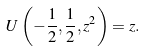Convert formula to latex. <formula><loc_0><loc_0><loc_500><loc_500>U \left ( - { \frac { 1 } { 2 } } , { \frac { 1 } { 2 } } , z ^ { 2 } \right ) = z .</formula> 